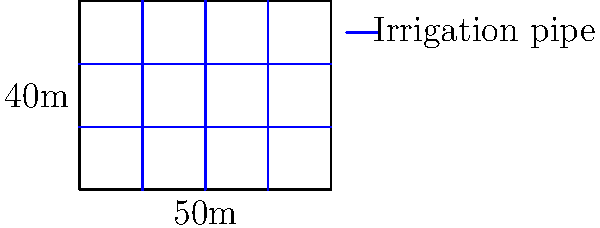You have a rectangular field measuring 50m by 40m that needs to be irrigated. The irrigation system consists of parallel pipes running both horizontally and vertically. If each pipe can effectively irrigate a strip of land 10m wide on either side, what is the minimum number of pipes needed to cover the entire field? Let's approach this step-by-step:

1) First, let's consider the horizontal pipes:
   - The field is 40m wide
   - Each pipe covers 20m (10m on each side)
   - So we need $\lceil 40 / 20 \rceil = 2$ horizontal pipes

2) Now for the vertical pipes:
   - The field is 50m long
   - Each pipe covers 20m (10m on each side)
   - So we need $\lceil 50 / 20 \rceil = 3$ vertical pipes

3) To calculate the total number of pipes:
   - Total pipes = Horizontal pipes + Vertical pipes
   - Total pipes = 2 + 3 = 5

4) Check: 
   - 2 horizontal pipes at 20m apart cover the 40m width
   - 3 vertical pipes at 20m apart cover the 50m length
   - This arrangement ensures full coverage of the field

Therefore, the minimum number of pipes needed is 5.
Answer: 5 pipes 